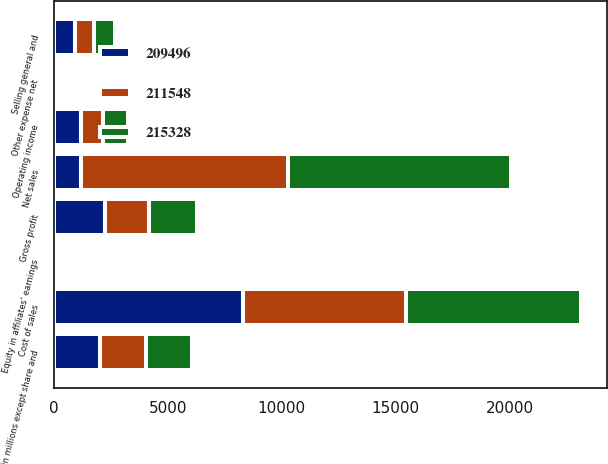<chart> <loc_0><loc_0><loc_500><loc_500><stacked_bar_chart><ecel><fcel>(in millions except share and<fcel>Net sales<fcel>Cost of sales<fcel>Gross profit<fcel>Selling general and<fcel>Other expense net<fcel>Operating income<fcel>Equity in affiliates' earnings<nl><fcel>209496<fcel>2018<fcel>1189.9<fcel>8300.2<fcel>2229.4<fcel>945.7<fcel>93.8<fcel>1189.9<fcel>48.9<nl><fcel>215328<fcel>2017<fcel>9799.3<fcel>7683.7<fcel>2115.6<fcel>899.1<fcel>144.5<fcel>1072<fcel>51.2<nl><fcel>211548<fcel>2016<fcel>9071<fcel>7142.3<fcel>1928.7<fcel>818<fcel>137.5<fcel>973.2<fcel>42.9<nl></chart> 